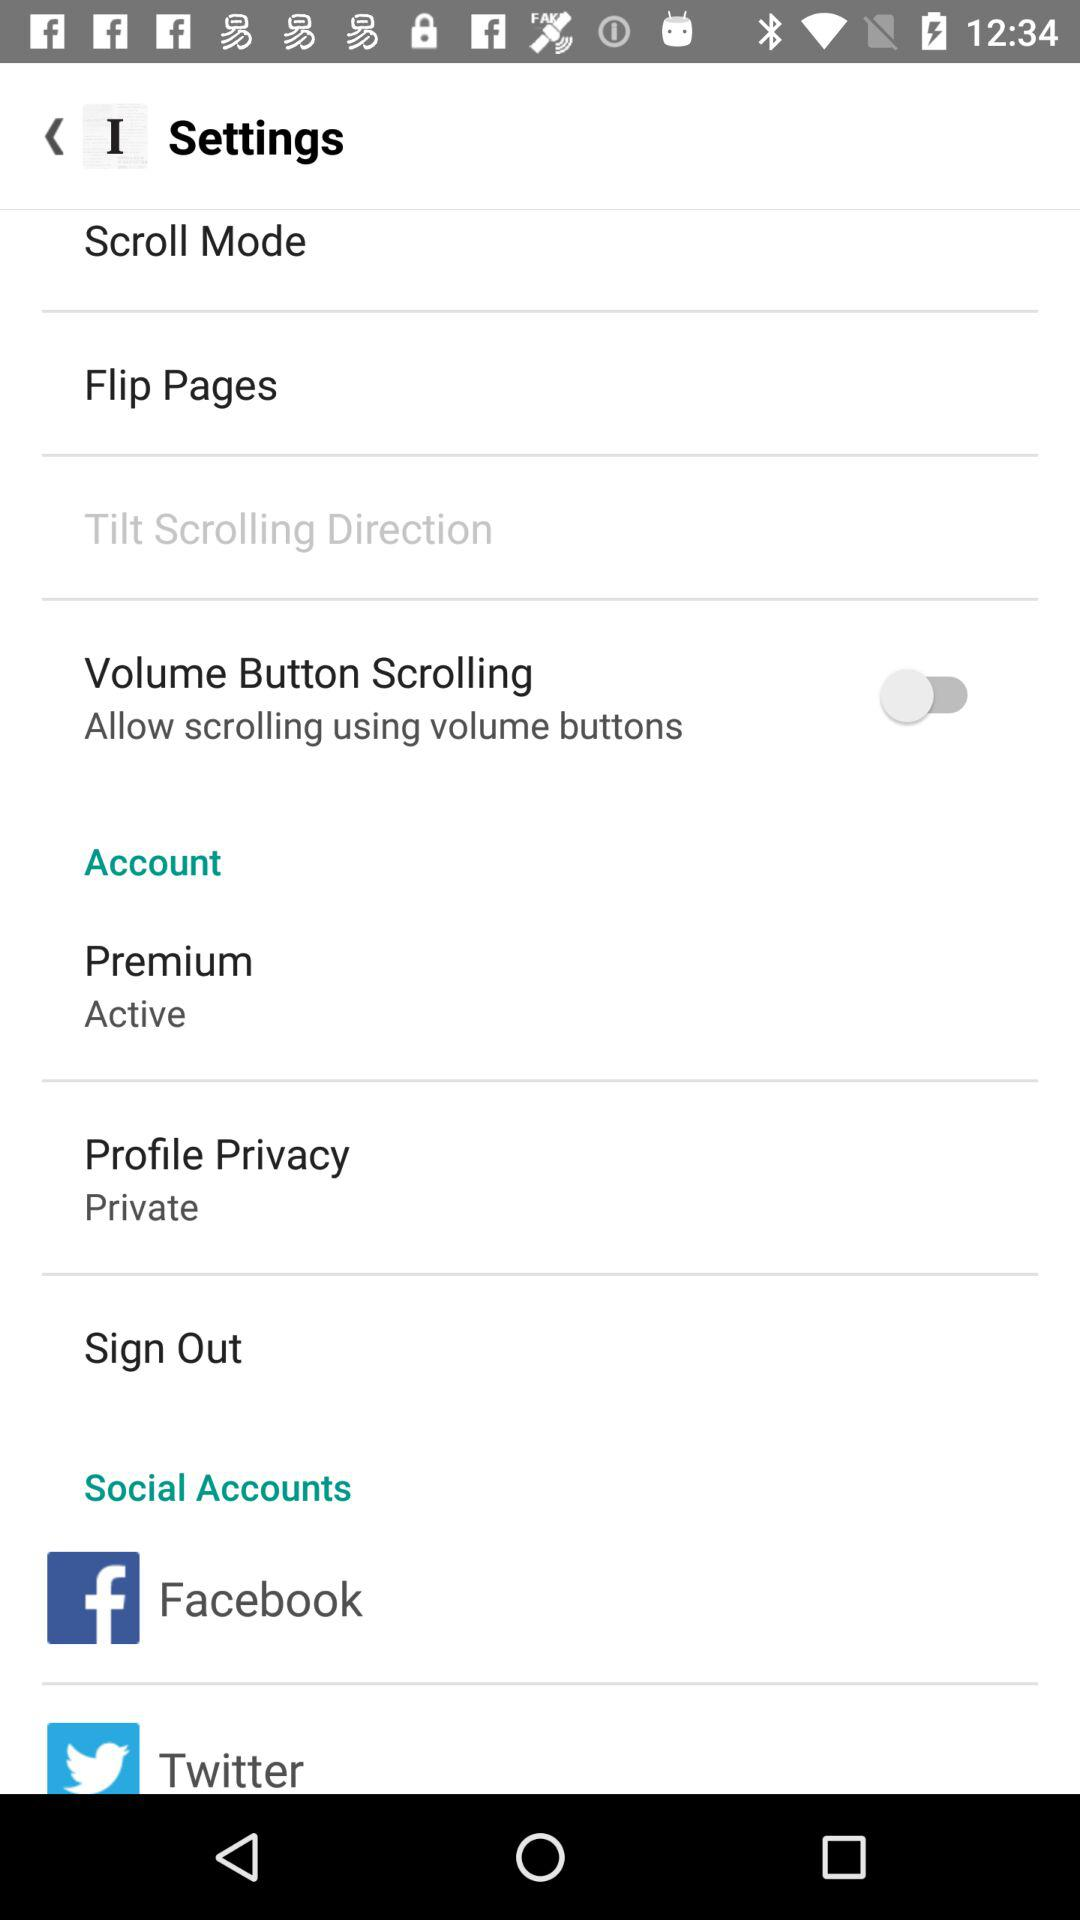How many items are in the social accounts section?
Answer the question using a single word or phrase. 2 